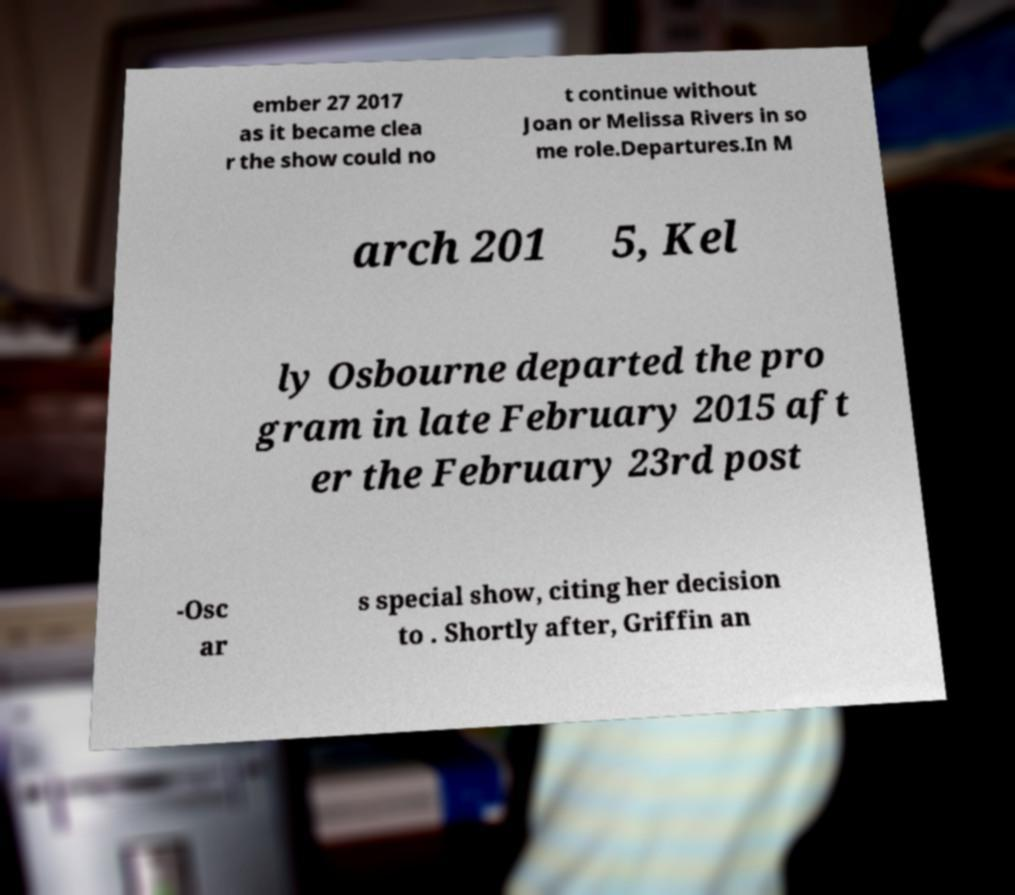What messages or text are displayed in this image? I need them in a readable, typed format. ember 27 2017 as it became clea r the show could no t continue without Joan or Melissa Rivers in so me role.Departures.In M arch 201 5, Kel ly Osbourne departed the pro gram in late February 2015 aft er the February 23rd post -Osc ar s special show, citing her decision to . Shortly after, Griffin an 